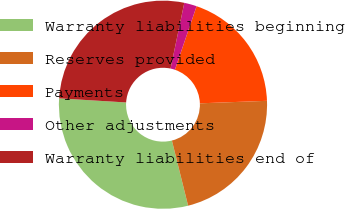Convert chart. <chart><loc_0><loc_0><loc_500><loc_500><pie_chart><fcel>Warranty liabilities beginning<fcel>Reserves provided<fcel>Payments<fcel>Other adjustments<fcel>Warranty liabilities end of<nl><fcel>29.85%<fcel>21.71%<fcel>19.17%<fcel>1.95%<fcel>27.31%<nl></chart> 